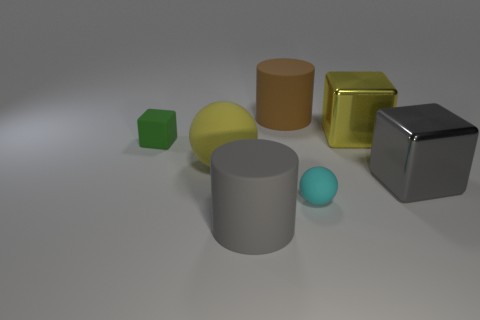Is there a gray block of the same size as the gray matte thing?
Offer a terse response. Yes. There is another shiny thing that is the same size as the gray shiny thing; what shape is it?
Your answer should be compact. Cube. What number of other things are there of the same color as the tiny block?
Your response must be concise. 0. There is a big matte object that is both in front of the small green rubber block and on the right side of the large rubber ball; what is its shape?
Your answer should be very brief. Cylinder. There is a large object that is in front of the cube that is in front of the big yellow rubber ball; is there a gray object that is on the right side of it?
Your answer should be compact. Yes. What number of other objects are there of the same material as the large gray block?
Offer a very short reply. 1. How many large gray metallic cubes are there?
Provide a short and direct response. 1. How many objects are either brown things or metallic objects that are to the right of the big brown rubber object?
Offer a very short reply. 3. Is there any other thing that is the same shape as the large gray matte object?
Keep it short and to the point. Yes. Does the shiny thing that is behind the green rubber object have the same size as the big brown rubber object?
Offer a terse response. Yes. 